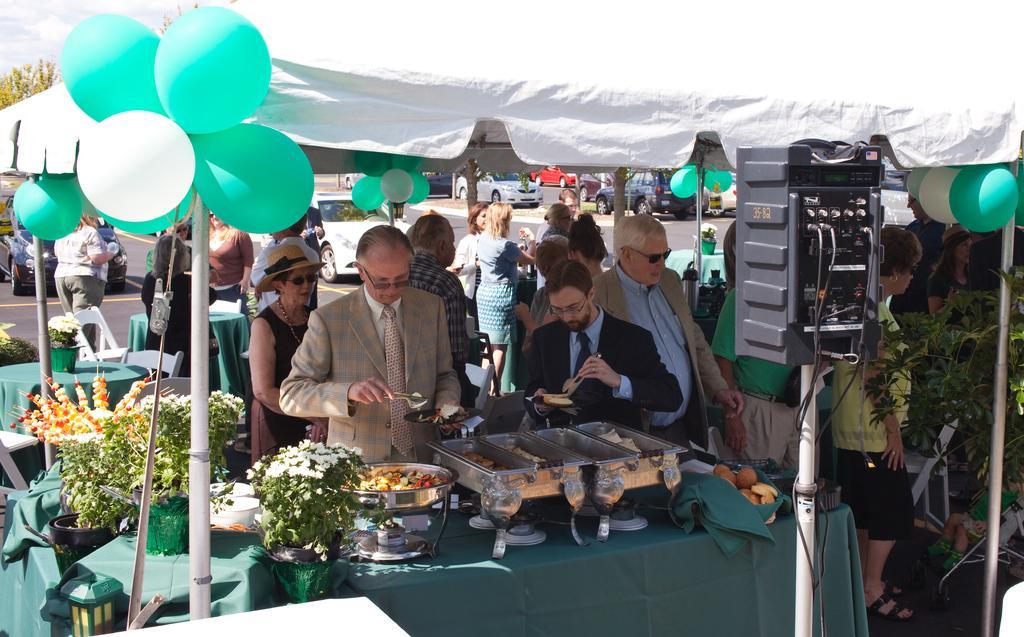Please provide a concise description of this image. In this picture I can see a table on which there are food items and I see plants on which there are flowers and I see the balloons which are of white and green in color and I see number of people who are standing. In the background I see the cars on the road and I see a white color cloth in front and behind the cloth I see an equipment. 